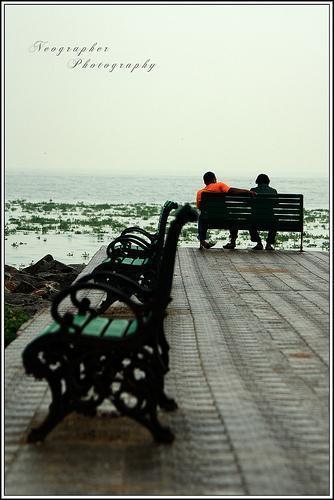How many people are there?
Give a very brief answer. 2. 